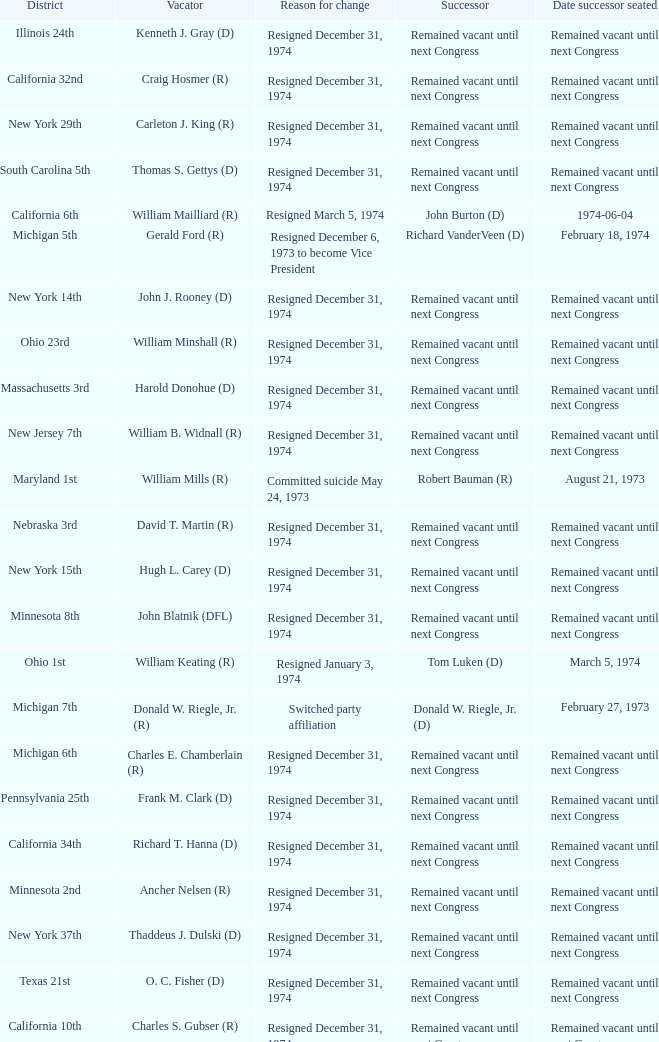Who was the vacator when the date successor seated was august 21, 1973? William Mills (R). 